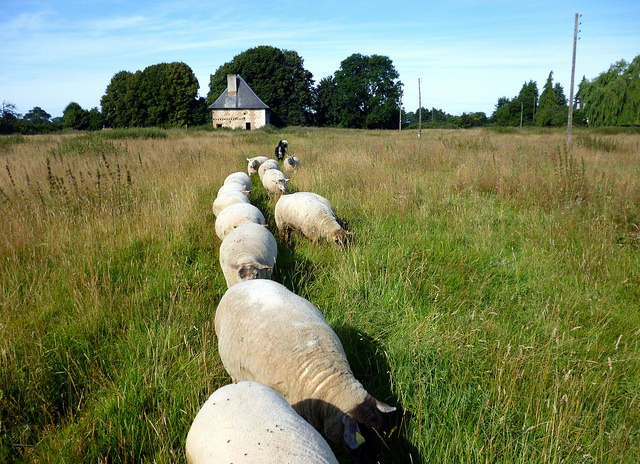Describe the objects in this image and their specific colors. I can see sheep in lightblue, tan, lightgray, and black tones, sheep in lightblue, ivory, darkgray, lightgray, and gray tones, sheep in lightblue, beige, tan, darkgray, and gray tones, sheep in lightblue, ivory, and tan tones, and sheep in lightblue, ivory, tan, darkgray, and gray tones in this image. 